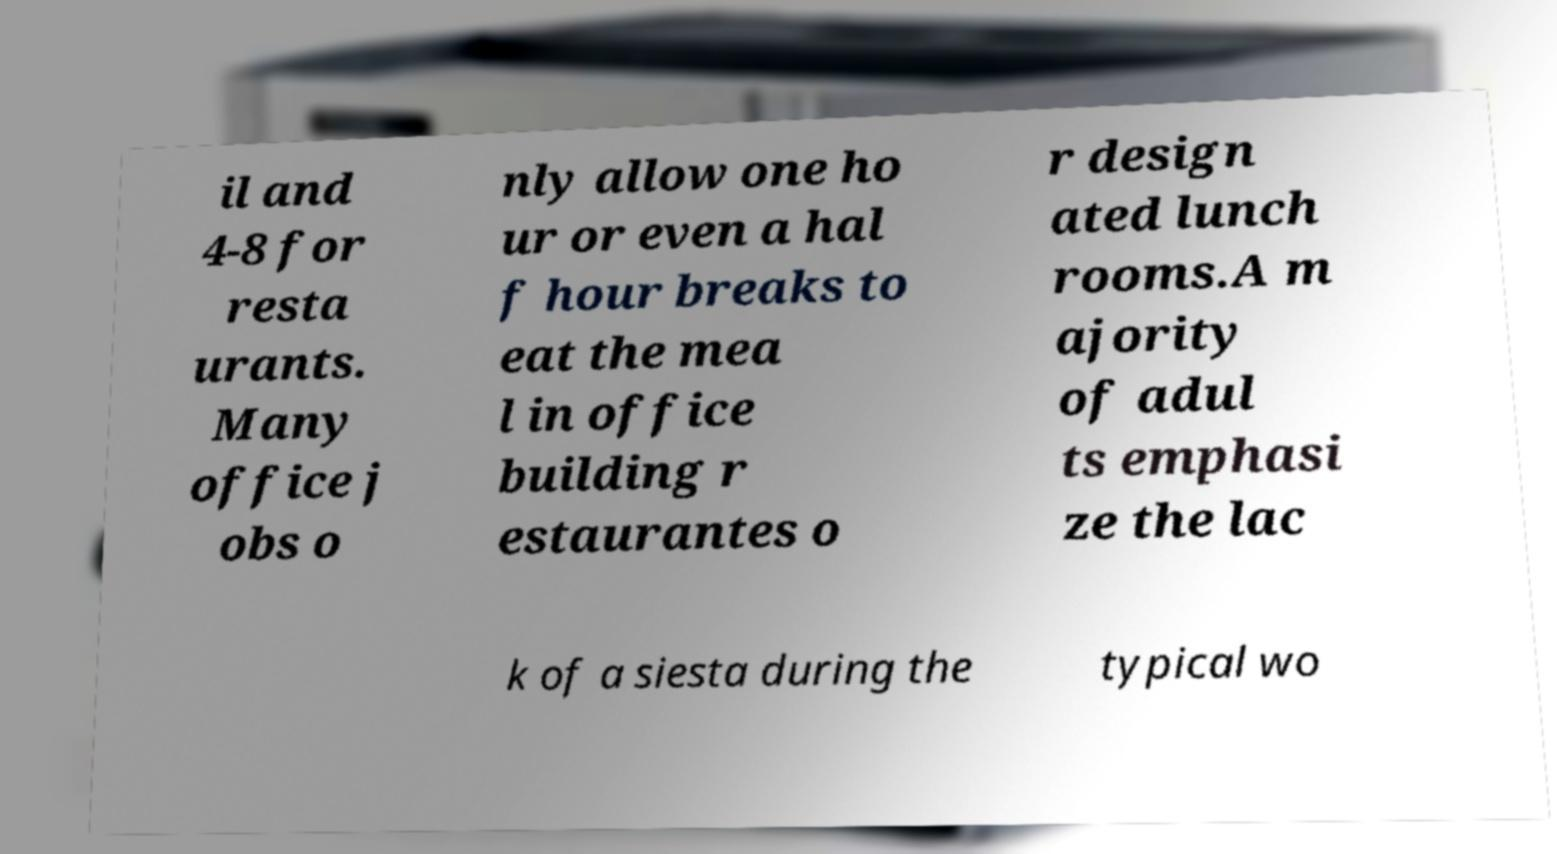What messages or text are displayed in this image? I need them in a readable, typed format. il and 4-8 for resta urants. Many office j obs o nly allow one ho ur or even a hal f hour breaks to eat the mea l in office building r estaurantes o r design ated lunch rooms.A m ajority of adul ts emphasi ze the lac k of a siesta during the typical wo 